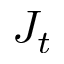<formula> <loc_0><loc_0><loc_500><loc_500>J _ { t }</formula> 